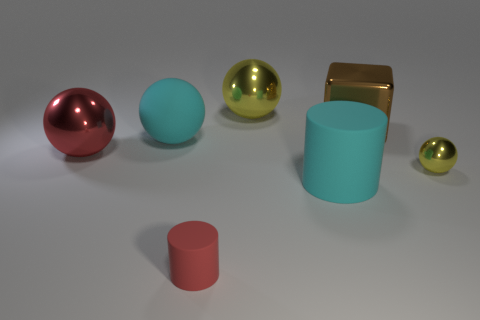Add 3 small shiny objects. How many objects exist? 10 Subtract all brown spheres. Subtract all yellow blocks. How many spheres are left? 4 Subtract all cylinders. How many objects are left? 5 Subtract all blue metal things. Subtract all red rubber cylinders. How many objects are left? 6 Add 2 big brown cubes. How many big brown cubes are left? 3 Add 1 cyan spheres. How many cyan spheres exist? 2 Subtract 0 cyan cubes. How many objects are left? 7 